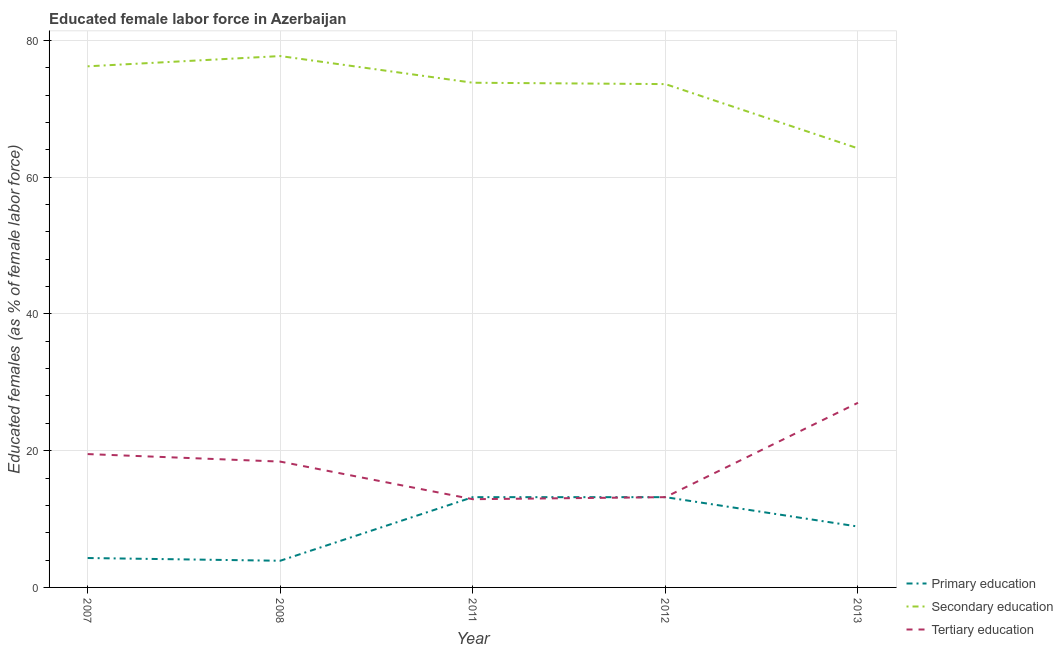How many different coloured lines are there?
Provide a succinct answer. 3. Does the line corresponding to percentage of female labor force who received secondary education intersect with the line corresponding to percentage of female labor force who received primary education?
Keep it short and to the point. No. What is the percentage of female labor force who received secondary education in 2011?
Your answer should be compact. 73.8. Across all years, what is the maximum percentage of female labor force who received secondary education?
Give a very brief answer. 77.7. Across all years, what is the minimum percentage of female labor force who received tertiary education?
Make the answer very short. 12.9. In which year was the percentage of female labor force who received primary education maximum?
Your answer should be compact. 2011. What is the total percentage of female labor force who received primary education in the graph?
Your answer should be compact. 43.5. What is the difference between the percentage of female labor force who received tertiary education in 2011 and that in 2013?
Provide a succinct answer. -14.1. What is the difference between the percentage of female labor force who received primary education in 2013 and the percentage of female labor force who received tertiary education in 2007?
Ensure brevity in your answer.  -10.6. What is the average percentage of female labor force who received tertiary education per year?
Your answer should be very brief. 18.2. In the year 2013, what is the difference between the percentage of female labor force who received primary education and percentage of female labor force who received tertiary education?
Your answer should be compact. -18.1. In how many years, is the percentage of female labor force who received primary education greater than 60 %?
Give a very brief answer. 0. What is the ratio of the percentage of female labor force who received primary education in 2011 to that in 2013?
Your answer should be very brief. 1.48. Is the percentage of female labor force who received primary education in 2007 less than that in 2011?
Keep it short and to the point. Yes. Is the difference between the percentage of female labor force who received primary education in 2012 and 2013 greater than the difference between the percentage of female labor force who received secondary education in 2012 and 2013?
Give a very brief answer. No. What is the difference between the highest and the second highest percentage of female labor force who received secondary education?
Offer a terse response. 1.5. What is the difference between the highest and the lowest percentage of female labor force who received tertiary education?
Offer a very short reply. 14.1. In how many years, is the percentage of female labor force who received tertiary education greater than the average percentage of female labor force who received tertiary education taken over all years?
Give a very brief answer. 3. Is the sum of the percentage of female labor force who received secondary education in 2011 and 2013 greater than the maximum percentage of female labor force who received primary education across all years?
Provide a succinct answer. Yes. Is it the case that in every year, the sum of the percentage of female labor force who received primary education and percentage of female labor force who received secondary education is greater than the percentage of female labor force who received tertiary education?
Keep it short and to the point. Yes. Is the percentage of female labor force who received primary education strictly less than the percentage of female labor force who received secondary education over the years?
Provide a short and direct response. Yes. Does the graph contain grids?
Provide a short and direct response. Yes. Where does the legend appear in the graph?
Make the answer very short. Bottom right. How are the legend labels stacked?
Your answer should be compact. Vertical. What is the title of the graph?
Ensure brevity in your answer.  Educated female labor force in Azerbaijan. Does "Ages 20-60" appear as one of the legend labels in the graph?
Keep it short and to the point. No. What is the label or title of the Y-axis?
Ensure brevity in your answer.  Educated females (as % of female labor force). What is the Educated females (as % of female labor force) of Primary education in 2007?
Your answer should be very brief. 4.3. What is the Educated females (as % of female labor force) in Secondary education in 2007?
Your response must be concise. 76.2. What is the Educated females (as % of female labor force) of Tertiary education in 2007?
Provide a succinct answer. 19.5. What is the Educated females (as % of female labor force) of Primary education in 2008?
Offer a very short reply. 3.9. What is the Educated females (as % of female labor force) of Secondary education in 2008?
Your response must be concise. 77.7. What is the Educated females (as % of female labor force) in Tertiary education in 2008?
Your answer should be very brief. 18.4. What is the Educated females (as % of female labor force) of Primary education in 2011?
Keep it short and to the point. 13.2. What is the Educated females (as % of female labor force) in Secondary education in 2011?
Make the answer very short. 73.8. What is the Educated females (as % of female labor force) in Tertiary education in 2011?
Your response must be concise. 12.9. What is the Educated females (as % of female labor force) of Primary education in 2012?
Keep it short and to the point. 13.2. What is the Educated females (as % of female labor force) of Secondary education in 2012?
Your answer should be compact. 73.6. What is the Educated females (as % of female labor force) of Tertiary education in 2012?
Keep it short and to the point. 13.2. What is the Educated females (as % of female labor force) in Primary education in 2013?
Offer a terse response. 8.9. What is the Educated females (as % of female labor force) in Secondary education in 2013?
Your answer should be very brief. 64.2. Across all years, what is the maximum Educated females (as % of female labor force) in Primary education?
Offer a terse response. 13.2. Across all years, what is the maximum Educated females (as % of female labor force) of Secondary education?
Give a very brief answer. 77.7. Across all years, what is the maximum Educated females (as % of female labor force) of Tertiary education?
Offer a very short reply. 27. Across all years, what is the minimum Educated females (as % of female labor force) in Primary education?
Your answer should be very brief. 3.9. Across all years, what is the minimum Educated females (as % of female labor force) of Secondary education?
Your answer should be very brief. 64.2. Across all years, what is the minimum Educated females (as % of female labor force) in Tertiary education?
Ensure brevity in your answer.  12.9. What is the total Educated females (as % of female labor force) of Primary education in the graph?
Offer a terse response. 43.5. What is the total Educated females (as % of female labor force) in Secondary education in the graph?
Provide a succinct answer. 365.5. What is the total Educated females (as % of female labor force) of Tertiary education in the graph?
Provide a short and direct response. 91. What is the difference between the Educated females (as % of female labor force) of Primary education in 2007 and that in 2011?
Give a very brief answer. -8.9. What is the difference between the Educated females (as % of female labor force) of Secondary education in 2007 and that in 2011?
Keep it short and to the point. 2.4. What is the difference between the Educated females (as % of female labor force) in Secondary education in 2007 and that in 2012?
Your answer should be very brief. 2.6. What is the difference between the Educated females (as % of female labor force) in Tertiary education in 2007 and that in 2013?
Make the answer very short. -7.5. What is the difference between the Educated females (as % of female labor force) of Tertiary education in 2008 and that in 2011?
Your answer should be compact. 5.5. What is the difference between the Educated females (as % of female labor force) in Primary education in 2008 and that in 2012?
Your answer should be compact. -9.3. What is the difference between the Educated females (as % of female labor force) in Secondary education in 2008 and that in 2012?
Your response must be concise. 4.1. What is the difference between the Educated females (as % of female labor force) in Tertiary education in 2008 and that in 2012?
Keep it short and to the point. 5.2. What is the difference between the Educated females (as % of female labor force) in Primary education in 2008 and that in 2013?
Make the answer very short. -5. What is the difference between the Educated females (as % of female labor force) of Secondary education in 2008 and that in 2013?
Give a very brief answer. 13.5. What is the difference between the Educated females (as % of female labor force) of Tertiary education in 2008 and that in 2013?
Provide a short and direct response. -8.6. What is the difference between the Educated females (as % of female labor force) in Primary education in 2011 and that in 2012?
Offer a terse response. 0. What is the difference between the Educated females (as % of female labor force) of Primary education in 2011 and that in 2013?
Give a very brief answer. 4.3. What is the difference between the Educated females (as % of female labor force) in Tertiary education in 2011 and that in 2013?
Your answer should be very brief. -14.1. What is the difference between the Educated females (as % of female labor force) of Primary education in 2012 and that in 2013?
Keep it short and to the point. 4.3. What is the difference between the Educated females (as % of female labor force) of Primary education in 2007 and the Educated females (as % of female labor force) of Secondary education in 2008?
Your answer should be compact. -73.4. What is the difference between the Educated females (as % of female labor force) of Primary education in 2007 and the Educated females (as % of female labor force) of Tertiary education in 2008?
Your answer should be very brief. -14.1. What is the difference between the Educated females (as % of female labor force) in Secondary education in 2007 and the Educated females (as % of female labor force) in Tertiary education in 2008?
Offer a very short reply. 57.8. What is the difference between the Educated females (as % of female labor force) in Primary education in 2007 and the Educated females (as % of female labor force) in Secondary education in 2011?
Make the answer very short. -69.5. What is the difference between the Educated females (as % of female labor force) of Primary education in 2007 and the Educated females (as % of female labor force) of Tertiary education in 2011?
Offer a very short reply. -8.6. What is the difference between the Educated females (as % of female labor force) in Secondary education in 2007 and the Educated females (as % of female labor force) in Tertiary education in 2011?
Your answer should be very brief. 63.3. What is the difference between the Educated females (as % of female labor force) of Primary education in 2007 and the Educated females (as % of female labor force) of Secondary education in 2012?
Keep it short and to the point. -69.3. What is the difference between the Educated females (as % of female labor force) of Secondary education in 2007 and the Educated females (as % of female labor force) of Tertiary education in 2012?
Give a very brief answer. 63. What is the difference between the Educated females (as % of female labor force) of Primary education in 2007 and the Educated females (as % of female labor force) of Secondary education in 2013?
Give a very brief answer. -59.9. What is the difference between the Educated females (as % of female labor force) in Primary education in 2007 and the Educated females (as % of female labor force) in Tertiary education in 2013?
Your response must be concise. -22.7. What is the difference between the Educated females (as % of female labor force) in Secondary education in 2007 and the Educated females (as % of female labor force) in Tertiary education in 2013?
Provide a short and direct response. 49.2. What is the difference between the Educated females (as % of female labor force) in Primary education in 2008 and the Educated females (as % of female labor force) in Secondary education in 2011?
Your response must be concise. -69.9. What is the difference between the Educated females (as % of female labor force) in Primary education in 2008 and the Educated females (as % of female labor force) in Tertiary education in 2011?
Make the answer very short. -9. What is the difference between the Educated females (as % of female labor force) in Secondary education in 2008 and the Educated females (as % of female labor force) in Tertiary education in 2011?
Offer a terse response. 64.8. What is the difference between the Educated females (as % of female labor force) in Primary education in 2008 and the Educated females (as % of female labor force) in Secondary education in 2012?
Provide a succinct answer. -69.7. What is the difference between the Educated females (as % of female labor force) of Secondary education in 2008 and the Educated females (as % of female labor force) of Tertiary education in 2012?
Keep it short and to the point. 64.5. What is the difference between the Educated females (as % of female labor force) of Primary education in 2008 and the Educated females (as % of female labor force) of Secondary education in 2013?
Make the answer very short. -60.3. What is the difference between the Educated females (as % of female labor force) in Primary education in 2008 and the Educated females (as % of female labor force) in Tertiary education in 2013?
Your answer should be compact. -23.1. What is the difference between the Educated females (as % of female labor force) in Secondary education in 2008 and the Educated females (as % of female labor force) in Tertiary education in 2013?
Your answer should be very brief. 50.7. What is the difference between the Educated females (as % of female labor force) in Primary education in 2011 and the Educated females (as % of female labor force) in Secondary education in 2012?
Ensure brevity in your answer.  -60.4. What is the difference between the Educated females (as % of female labor force) of Primary education in 2011 and the Educated females (as % of female labor force) of Tertiary education in 2012?
Offer a terse response. 0. What is the difference between the Educated females (as % of female labor force) in Secondary education in 2011 and the Educated females (as % of female labor force) in Tertiary education in 2012?
Provide a short and direct response. 60.6. What is the difference between the Educated females (as % of female labor force) in Primary education in 2011 and the Educated females (as % of female labor force) in Secondary education in 2013?
Make the answer very short. -51. What is the difference between the Educated females (as % of female labor force) of Secondary education in 2011 and the Educated females (as % of female labor force) of Tertiary education in 2013?
Make the answer very short. 46.8. What is the difference between the Educated females (as % of female labor force) in Primary education in 2012 and the Educated females (as % of female labor force) in Secondary education in 2013?
Your answer should be very brief. -51. What is the difference between the Educated females (as % of female labor force) of Secondary education in 2012 and the Educated females (as % of female labor force) of Tertiary education in 2013?
Give a very brief answer. 46.6. What is the average Educated females (as % of female labor force) of Secondary education per year?
Offer a terse response. 73.1. What is the average Educated females (as % of female labor force) of Tertiary education per year?
Make the answer very short. 18.2. In the year 2007, what is the difference between the Educated females (as % of female labor force) of Primary education and Educated females (as % of female labor force) of Secondary education?
Offer a terse response. -71.9. In the year 2007, what is the difference between the Educated females (as % of female labor force) in Primary education and Educated females (as % of female labor force) in Tertiary education?
Offer a terse response. -15.2. In the year 2007, what is the difference between the Educated females (as % of female labor force) in Secondary education and Educated females (as % of female labor force) in Tertiary education?
Your answer should be compact. 56.7. In the year 2008, what is the difference between the Educated females (as % of female labor force) in Primary education and Educated females (as % of female labor force) in Secondary education?
Ensure brevity in your answer.  -73.8. In the year 2008, what is the difference between the Educated females (as % of female labor force) in Primary education and Educated females (as % of female labor force) in Tertiary education?
Offer a terse response. -14.5. In the year 2008, what is the difference between the Educated females (as % of female labor force) of Secondary education and Educated females (as % of female labor force) of Tertiary education?
Make the answer very short. 59.3. In the year 2011, what is the difference between the Educated females (as % of female labor force) of Primary education and Educated females (as % of female labor force) of Secondary education?
Your response must be concise. -60.6. In the year 2011, what is the difference between the Educated females (as % of female labor force) in Primary education and Educated females (as % of female labor force) in Tertiary education?
Keep it short and to the point. 0.3. In the year 2011, what is the difference between the Educated females (as % of female labor force) in Secondary education and Educated females (as % of female labor force) in Tertiary education?
Provide a succinct answer. 60.9. In the year 2012, what is the difference between the Educated females (as % of female labor force) in Primary education and Educated females (as % of female labor force) in Secondary education?
Make the answer very short. -60.4. In the year 2012, what is the difference between the Educated females (as % of female labor force) in Secondary education and Educated females (as % of female labor force) in Tertiary education?
Give a very brief answer. 60.4. In the year 2013, what is the difference between the Educated females (as % of female labor force) of Primary education and Educated females (as % of female labor force) of Secondary education?
Keep it short and to the point. -55.3. In the year 2013, what is the difference between the Educated females (as % of female labor force) in Primary education and Educated females (as % of female labor force) in Tertiary education?
Your response must be concise. -18.1. In the year 2013, what is the difference between the Educated females (as % of female labor force) of Secondary education and Educated females (as % of female labor force) of Tertiary education?
Give a very brief answer. 37.2. What is the ratio of the Educated females (as % of female labor force) of Primary education in 2007 to that in 2008?
Offer a terse response. 1.1. What is the ratio of the Educated females (as % of female labor force) in Secondary education in 2007 to that in 2008?
Give a very brief answer. 0.98. What is the ratio of the Educated females (as % of female labor force) of Tertiary education in 2007 to that in 2008?
Your answer should be compact. 1.06. What is the ratio of the Educated females (as % of female labor force) in Primary education in 2007 to that in 2011?
Offer a very short reply. 0.33. What is the ratio of the Educated females (as % of female labor force) of Secondary education in 2007 to that in 2011?
Your answer should be compact. 1.03. What is the ratio of the Educated females (as % of female labor force) in Tertiary education in 2007 to that in 2011?
Your answer should be compact. 1.51. What is the ratio of the Educated females (as % of female labor force) of Primary education in 2007 to that in 2012?
Your response must be concise. 0.33. What is the ratio of the Educated females (as % of female labor force) of Secondary education in 2007 to that in 2012?
Keep it short and to the point. 1.04. What is the ratio of the Educated females (as % of female labor force) in Tertiary education in 2007 to that in 2012?
Your answer should be very brief. 1.48. What is the ratio of the Educated females (as % of female labor force) of Primary education in 2007 to that in 2013?
Offer a very short reply. 0.48. What is the ratio of the Educated females (as % of female labor force) of Secondary education in 2007 to that in 2013?
Make the answer very short. 1.19. What is the ratio of the Educated females (as % of female labor force) of Tertiary education in 2007 to that in 2013?
Keep it short and to the point. 0.72. What is the ratio of the Educated females (as % of female labor force) in Primary education in 2008 to that in 2011?
Ensure brevity in your answer.  0.3. What is the ratio of the Educated females (as % of female labor force) in Secondary education in 2008 to that in 2011?
Make the answer very short. 1.05. What is the ratio of the Educated females (as % of female labor force) of Tertiary education in 2008 to that in 2011?
Keep it short and to the point. 1.43. What is the ratio of the Educated females (as % of female labor force) in Primary education in 2008 to that in 2012?
Offer a terse response. 0.3. What is the ratio of the Educated females (as % of female labor force) in Secondary education in 2008 to that in 2012?
Keep it short and to the point. 1.06. What is the ratio of the Educated females (as % of female labor force) in Tertiary education in 2008 to that in 2012?
Make the answer very short. 1.39. What is the ratio of the Educated females (as % of female labor force) in Primary education in 2008 to that in 2013?
Provide a succinct answer. 0.44. What is the ratio of the Educated females (as % of female labor force) in Secondary education in 2008 to that in 2013?
Give a very brief answer. 1.21. What is the ratio of the Educated females (as % of female labor force) in Tertiary education in 2008 to that in 2013?
Your answer should be very brief. 0.68. What is the ratio of the Educated females (as % of female labor force) in Tertiary education in 2011 to that in 2012?
Keep it short and to the point. 0.98. What is the ratio of the Educated females (as % of female labor force) in Primary education in 2011 to that in 2013?
Your answer should be compact. 1.48. What is the ratio of the Educated females (as % of female labor force) in Secondary education in 2011 to that in 2013?
Provide a succinct answer. 1.15. What is the ratio of the Educated females (as % of female labor force) of Tertiary education in 2011 to that in 2013?
Your answer should be very brief. 0.48. What is the ratio of the Educated females (as % of female labor force) in Primary education in 2012 to that in 2013?
Your answer should be very brief. 1.48. What is the ratio of the Educated females (as % of female labor force) of Secondary education in 2012 to that in 2013?
Provide a short and direct response. 1.15. What is the ratio of the Educated females (as % of female labor force) of Tertiary education in 2012 to that in 2013?
Make the answer very short. 0.49. What is the difference between the highest and the second highest Educated females (as % of female labor force) in Primary education?
Keep it short and to the point. 0. What is the difference between the highest and the lowest Educated females (as % of female labor force) in Secondary education?
Ensure brevity in your answer.  13.5. 